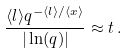<formula> <loc_0><loc_0><loc_500><loc_500>\frac { \langle l \rangle q ^ { - \langle l \rangle / \langle x \rangle } } { | \ln ( q ) | } \approx t \, .</formula> 